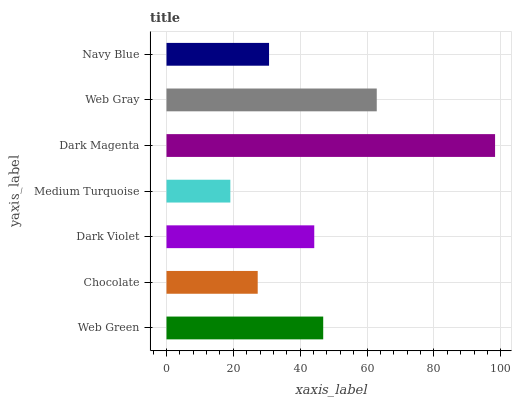Is Medium Turquoise the minimum?
Answer yes or no. Yes. Is Dark Magenta the maximum?
Answer yes or no. Yes. Is Chocolate the minimum?
Answer yes or no. No. Is Chocolate the maximum?
Answer yes or no. No. Is Web Green greater than Chocolate?
Answer yes or no. Yes. Is Chocolate less than Web Green?
Answer yes or no. Yes. Is Chocolate greater than Web Green?
Answer yes or no. No. Is Web Green less than Chocolate?
Answer yes or no. No. Is Dark Violet the high median?
Answer yes or no. Yes. Is Dark Violet the low median?
Answer yes or no. Yes. Is Chocolate the high median?
Answer yes or no. No. Is Web Gray the low median?
Answer yes or no. No. 